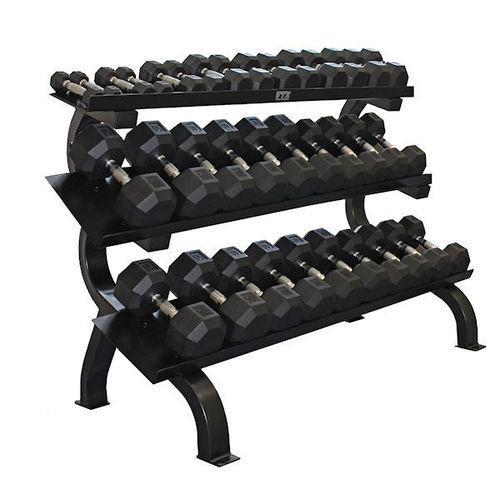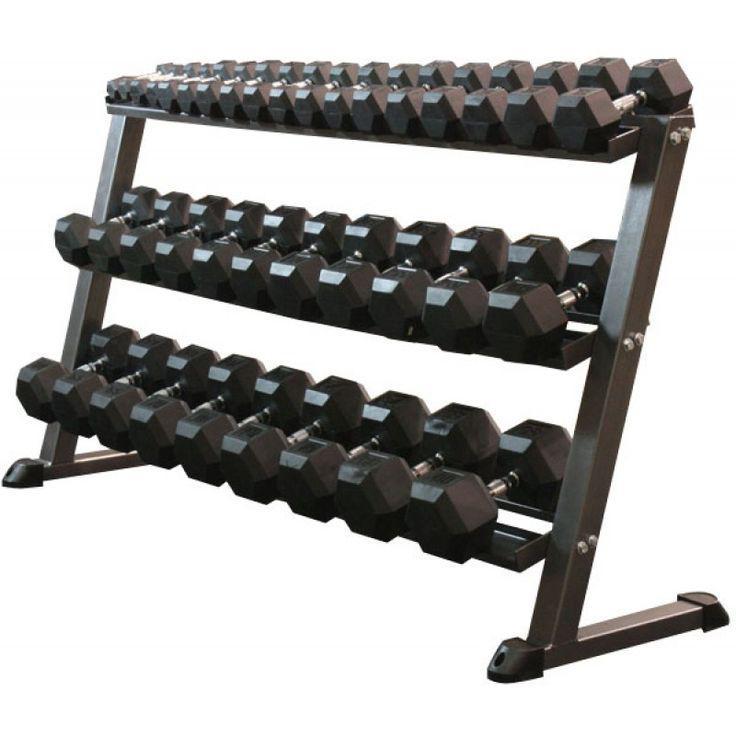The first image is the image on the left, the second image is the image on the right. Assess this claim about the two images: "There are six rows on weights with three rows in each image, and each image's rows of weights are facing opposite directions.". Correct or not? Answer yes or no. Yes. The first image is the image on the left, the second image is the image on the right. Evaluate the accuracy of this statement regarding the images: "One rack has three tiers to hold dumbbells, and the other rack has only two shelves for weights.". Is it true? Answer yes or no. No. 